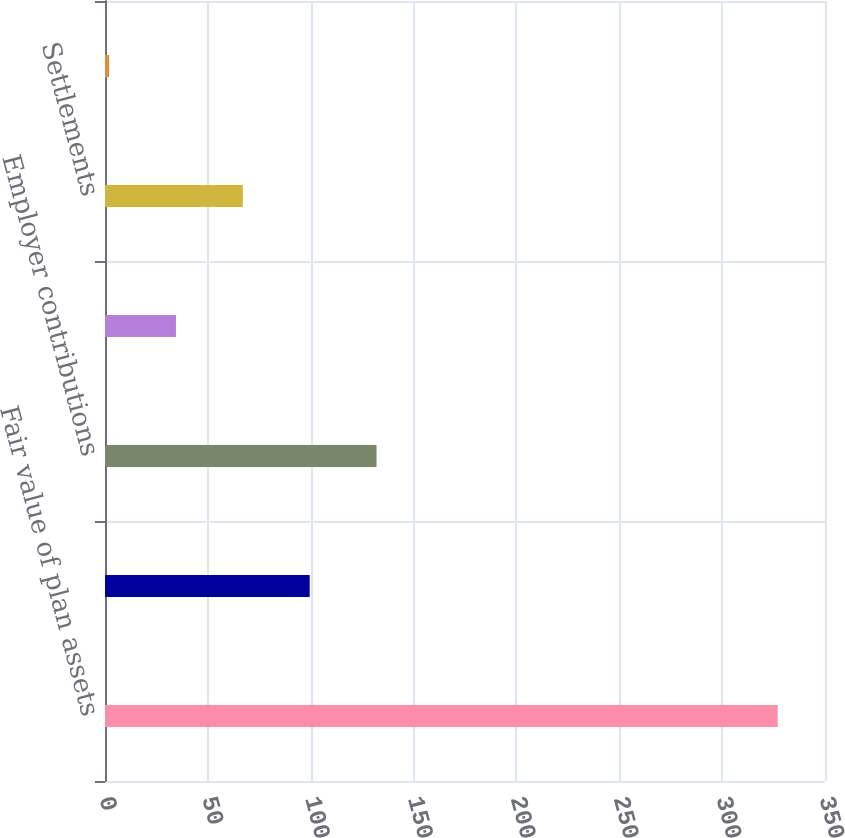Convert chart to OTSL. <chart><loc_0><loc_0><loc_500><loc_500><bar_chart><fcel>Fair value of plan assets<fcel>Actual return on plan assets<fcel>Employer contributions<fcel>Benefits paid<fcel>Settlements<fcel>Foreign currency rate changes<nl><fcel>327<fcel>99.5<fcel>132<fcel>34.5<fcel>67<fcel>2<nl></chart> 